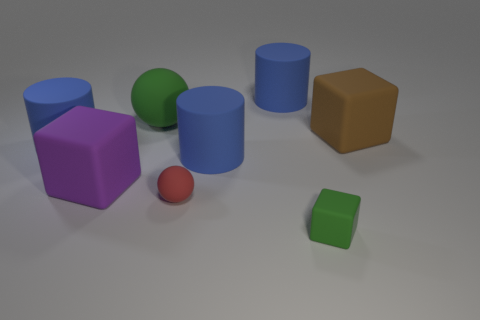Subtract all blue cylinders. How many were subtracted if there are1blue cylinders left? 2 Subtract all brown cubes. How many cubes are left? 2 Subtract all purple blocks. How many blocks are left? 2 Subtract 1 blocks. How many blocks are left? 2 Add 2 tiny green metallic spheres. How many objects exist? 10 Subtract 1 purple blocks. How many objects are left? 7 Subtract all spheres. How many objects are left? 6 Subtract all purple blocks. Subtract all brown balls. How many blocks are left? 2 Subtract all cyan cylinders. How many green blocks are left? 1 Subtract all blue rubber objects. Subtract all big green rubber spheres. How many objects are left? 4 